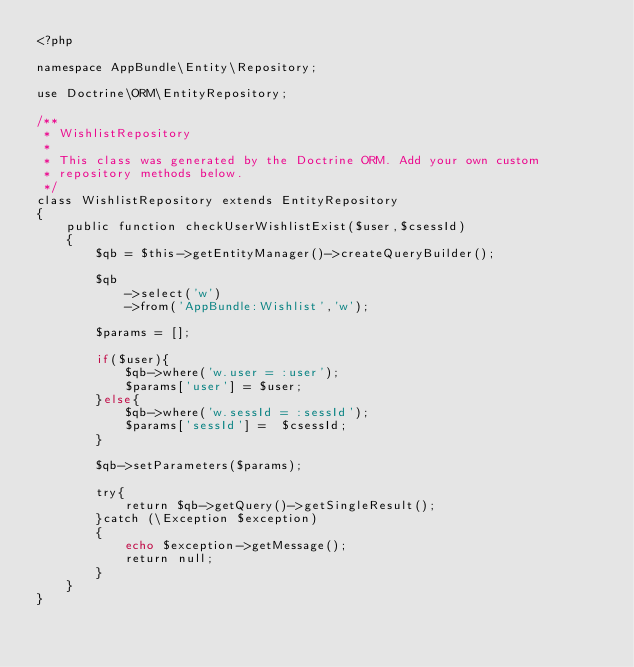<code> <loc_0><loc_0><loc_500><loc_500><_PHP_><?php

namespace AppBundle\Entity\Repository;

use Doctrine\ORM\EntityRepository;

/**
 * WishlistRepository
 *
 * This class was generated by the Doctrine ORM. Add your own custom
 * repository methods below.
 */
class WishlistRepository extends EntityRepository
{
    public function checkUserWishlistExist($user,$csessId)
    {
        $qb = $this->getEntityManager()->createQueryBuilder();

        $qb
            ->select('w')
            ->from('AppBundle:Wishlist','w');

        $params = [];

        if($user){
            $qb->where('w.user = :user');
            $params['user'] = $user;
        }else{
            $qb->where('w.sessId = :sessId');
            $params['sessId'] =  $csessId;
        }

        $qb->setParameters($params);

        try{
            return $qb->getQuery()->getSingleResult();
        }catch (\Exception $exception)
        {
            echo $exception->getMessage();
            return null;
        }
    }
}
</code> 